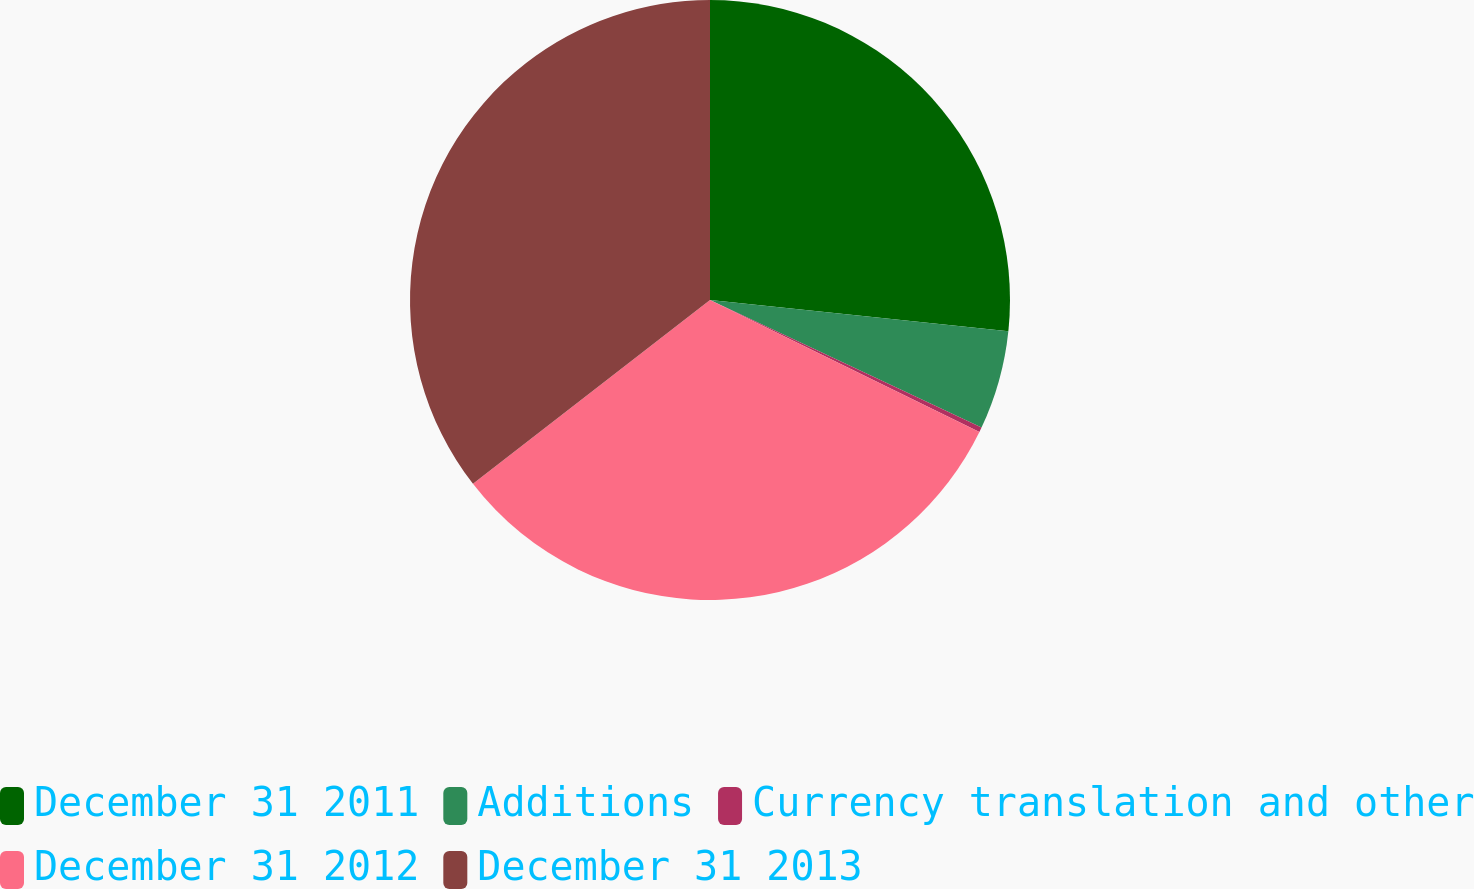<chart> <loc_0><loc_0><loc_500><loc_500><pie_chart><fcel>December 31 2011<fcel>Additions<fcel>Currency translation and other<fcel>December 31 2012<fcel>December 31 2013<nl><fcel>26.66%<fcel>5.33%<fcel>0.26%<fcel>32.25%<fcel>35.5%<nl></chart> 